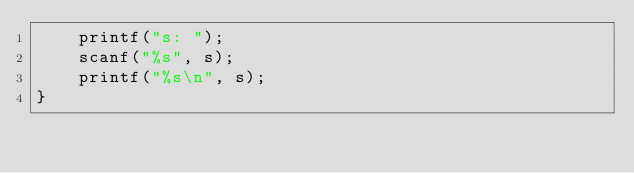Convert code to text. <code><loc_0><loc_0><loc_500><loc_500><_C_>    printf("s: ");
    scanf("%s", s);
    printf("%s\n", s);
}
</code> 